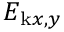<formula> <loc_0><loc_0><loc_500><loc_500>E _ { k x , y }</formula> 